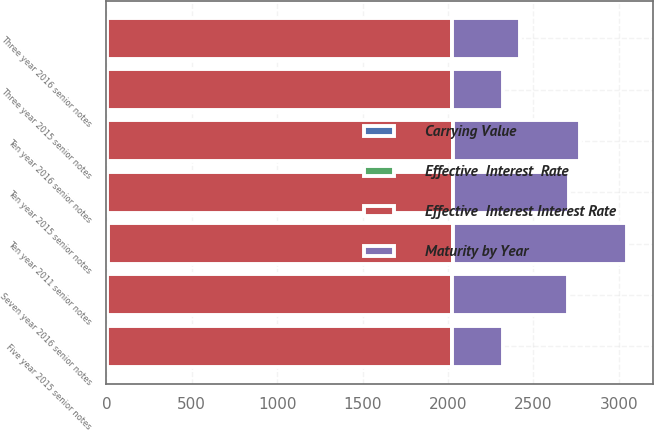<chart> <loc_0><loc_0><loc_500><loc_500><stacked_bar_chart><ecel><fcel>Three year 2015 senior notes<fcel>Three year 2016 senior notes<fcel>Five year 2015 senior notes<fcel>Ten year 2011 senior notes<fcel>Seven year 2016 senior notes<fcel>Ten year 2015 senior notes<fcel>Ten year 2016 senior notes<nl><fcel>Effective  Interest Interest Rate<fcel>2018<fcel>2019<fcel>2020<fcel>2021<fcel>2024<fcel>2025<fcel>2026<nl><fcel>Maturity by Year<fcel>299.9<fcel>396.1<fcel>299.1<fcel>1016.6<fcel>676.6<fcel>679.4<fcel>742.8<nl><fcel>Carrying Value<fcel>1.55<fcel>2<fcel>2.25<fcel>4.35<fcel>1<fcel>2.63<fcel>2.7<nl><fcel>Effective  Interest  Rate<fcel>1.94<fcel>2.26<fcel>2.79<fcel>4.45<fcel>1.17<fcel>2.85<fcel>2.93<nl></chart> 